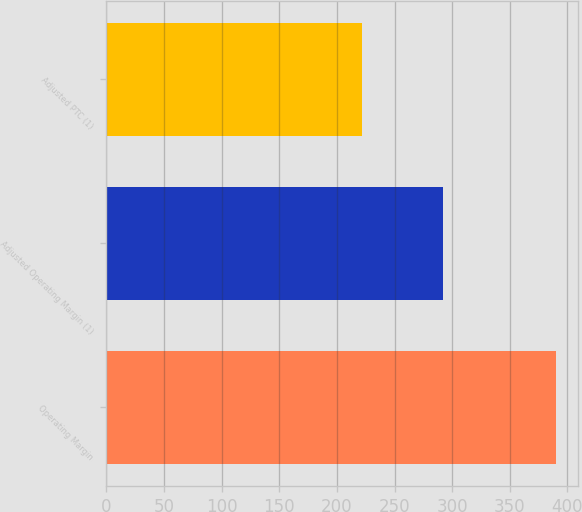<chart> <loc_0><loc_0><loc_500><loc_500><bar_chart><fcel>Operating Margin<fcel>Adjusted Operating Margin (1)<fcel>Adjusted PTC (1)<nl><fcel>390<fcel>292<fcel>222<nl></chart> 